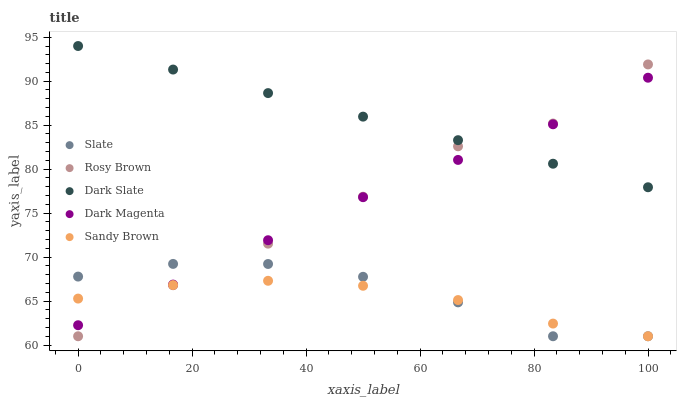Does Sandy Brown have the minimum area under the curve?
Answer yes or no. Yes. Does Dark Slate have the maximum area under the curve?
Answer yes or no. Yes. Does Slate have the minimum area under the curve?
Answer yes or no. No. Does Slate have the maximum area under the curve?
Answer yes or no. No. Is Dark Slate the smoothest?
Answer yes or no. Yes. Is Rosy Brown the roughest?
Answer yes or no. Yes. Is Slate the smoothest?
Answer yes or no. No. Is Slate the roughest?
Answer yes or no. No. Does Slate have the lowest value?
Answer yes or no. Yes. Does Dark Magenta have the lowest value?
Answer yes or no. No. Does Dark Slate have the highest value?
Answer yes or no. Yes. Does Slate have the highest value?
Answer yes or no. No. Is Slate less than Dark Slate?
Answer yes or no. Yes. Is Dark Slate greater than Slate?
Answer yes or no. Yes. Does Sandy Brown intersect Dark Magenta?
Answer yes or no. Yes. Is Sandy Brown less than Dark Magenta?
Answer yes or no. No. Is Sandy Brown greater than Dark Magenta?
Answer yes or no. No. Does Slate intersect Dark Slate?
Answer yes or no. No. 